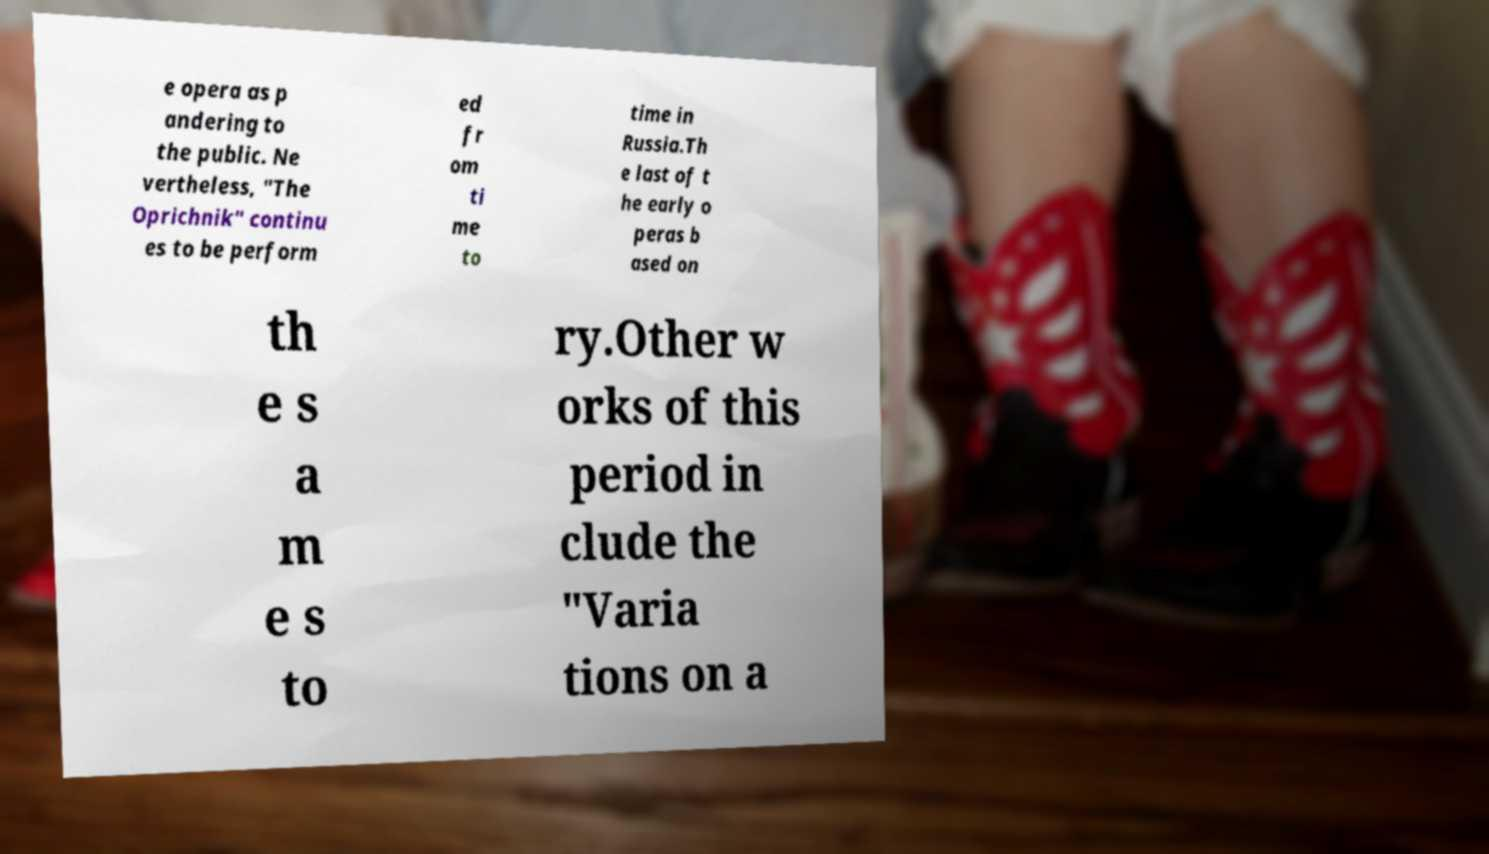Could you assist in decoding the text presented in this image and type it out clearly? e opera as p andering to the public. Ne vertheless, "The Oprichnik" continu es to be perform ed fr om ti me to time in Russia.Th e last of t he early o peras b ased on th e s a m e s to ry.Other w orks of this period in clude the "Varia tions on a 